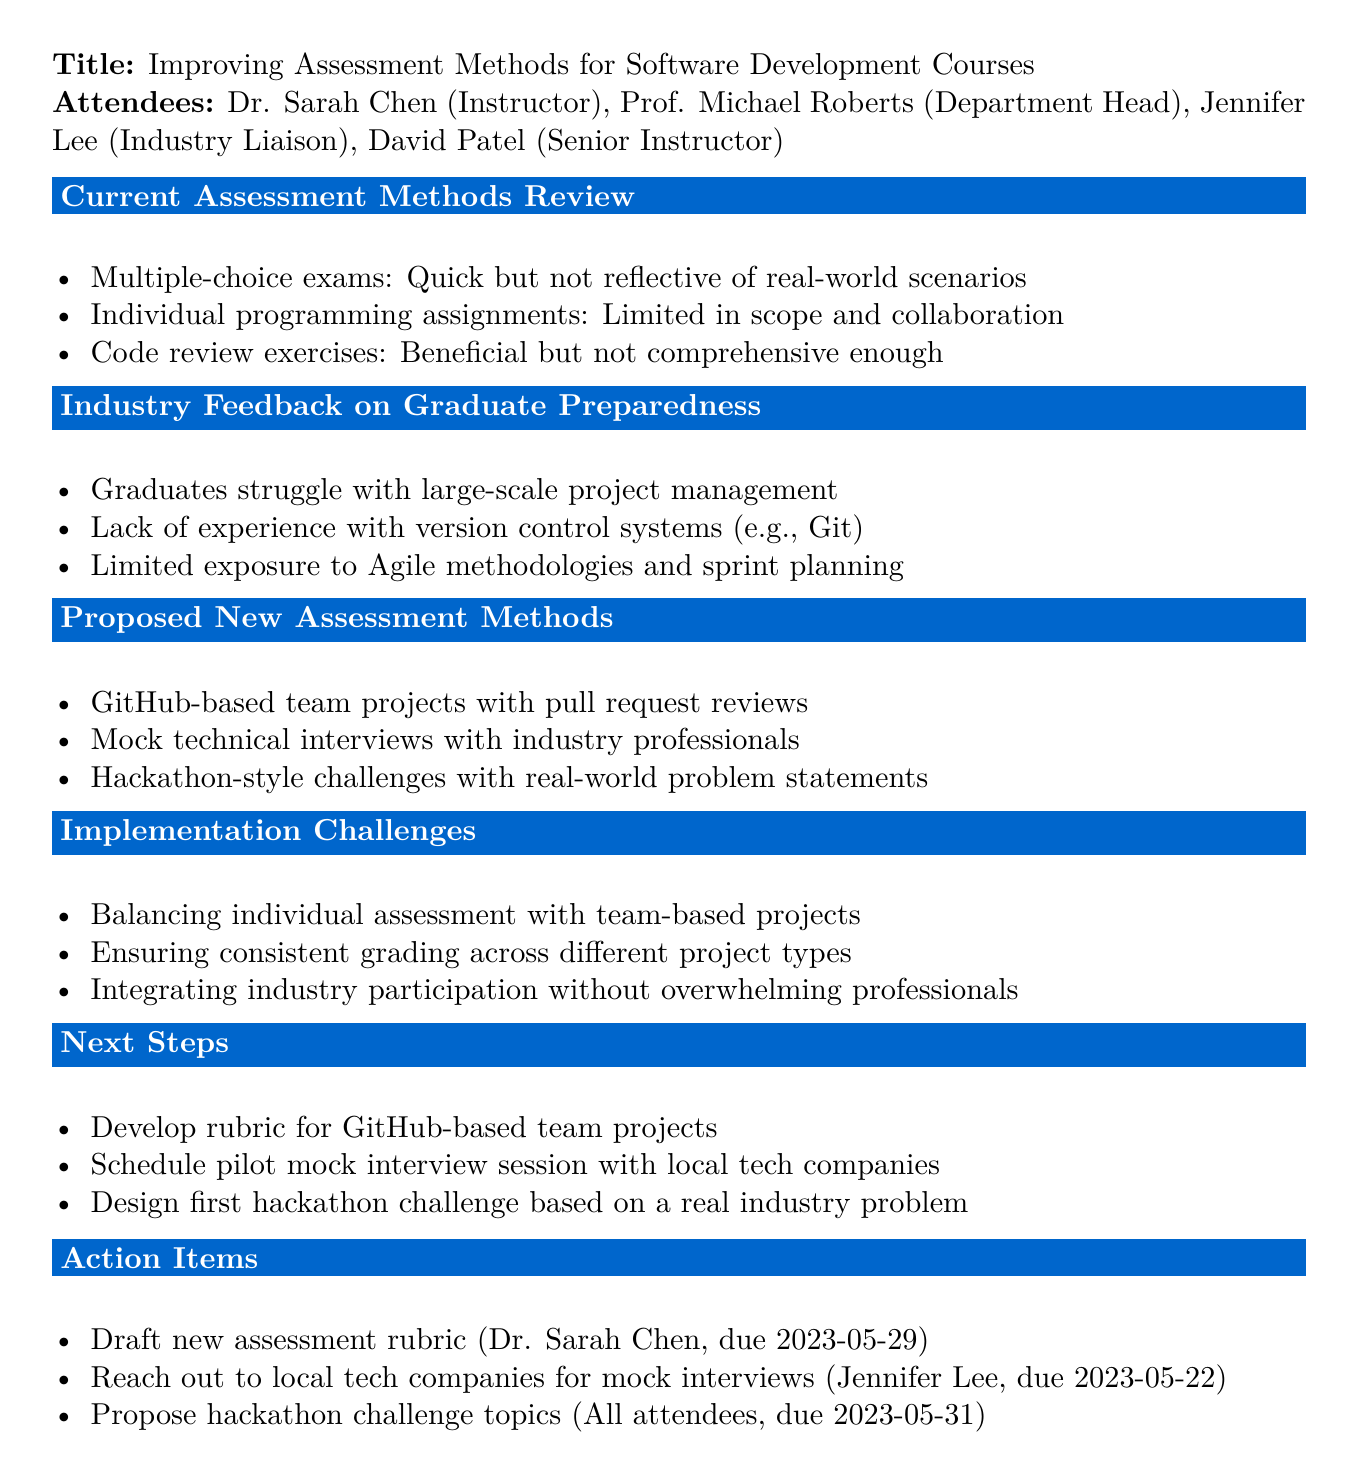What is the date of the meeting? The date of the meeting is mentioned in the document's header.
Answer: 2023-05-15 Who is the Industry Liaison? The document lists attendees, including their roles.
Answer: Jennifer Lee What type of assessment is currently limited in scope and collaboration? The document points out various assessment methods and their limitations.
Answer: Individual programming assignments What is one proposed new assessment method? The document lists several proposed methods for improvement.
Answer: GitHub-based team projects with pull request reviews What is a challenge in implementing new assessment methods? The document identifies challenges that need to be addressed during implementation.
Answer: Balancing individual assessment with team-based projects Who is assigned to draft the new assessment rubric? The action items specify who is responsible for each task.
Answer: Dr. Sarah Chen What is the due date for reaching out to local tech companies for mock interviews? The document explicitly states the due dates for action items.
Answer: 2023-05-22 What assessment method do graduates lack experience with? The document mentions feedback regarding areas where graduates struggle.
Answer: Version control systems (e.g., Git) What is the purpose of the proposed hackathon challenges? The document states the intent of introducing hackathon-style challenges.
Answer: Real-world problem statements 